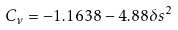<formula> <loc_0><loc_0><loc_500><loc_500>C _ { \nu } = - 1 . 1 6 3 8 - 4 . 8 8 \delta s ^ { 2 }</formula> 